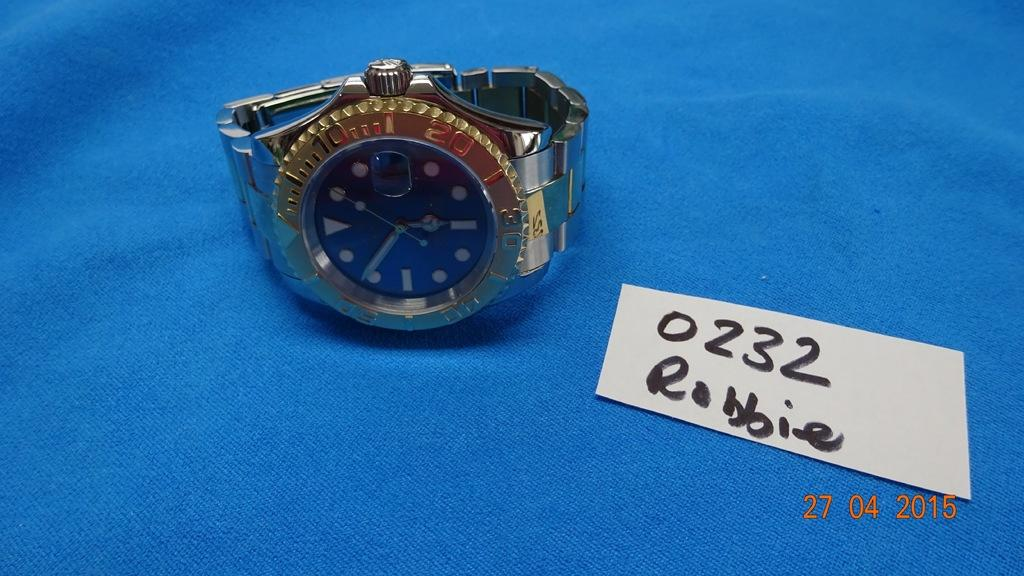Provide a one-sentence caption for the provided image. A wristwatch sits next to a numbered card with the name Robbie on it. 